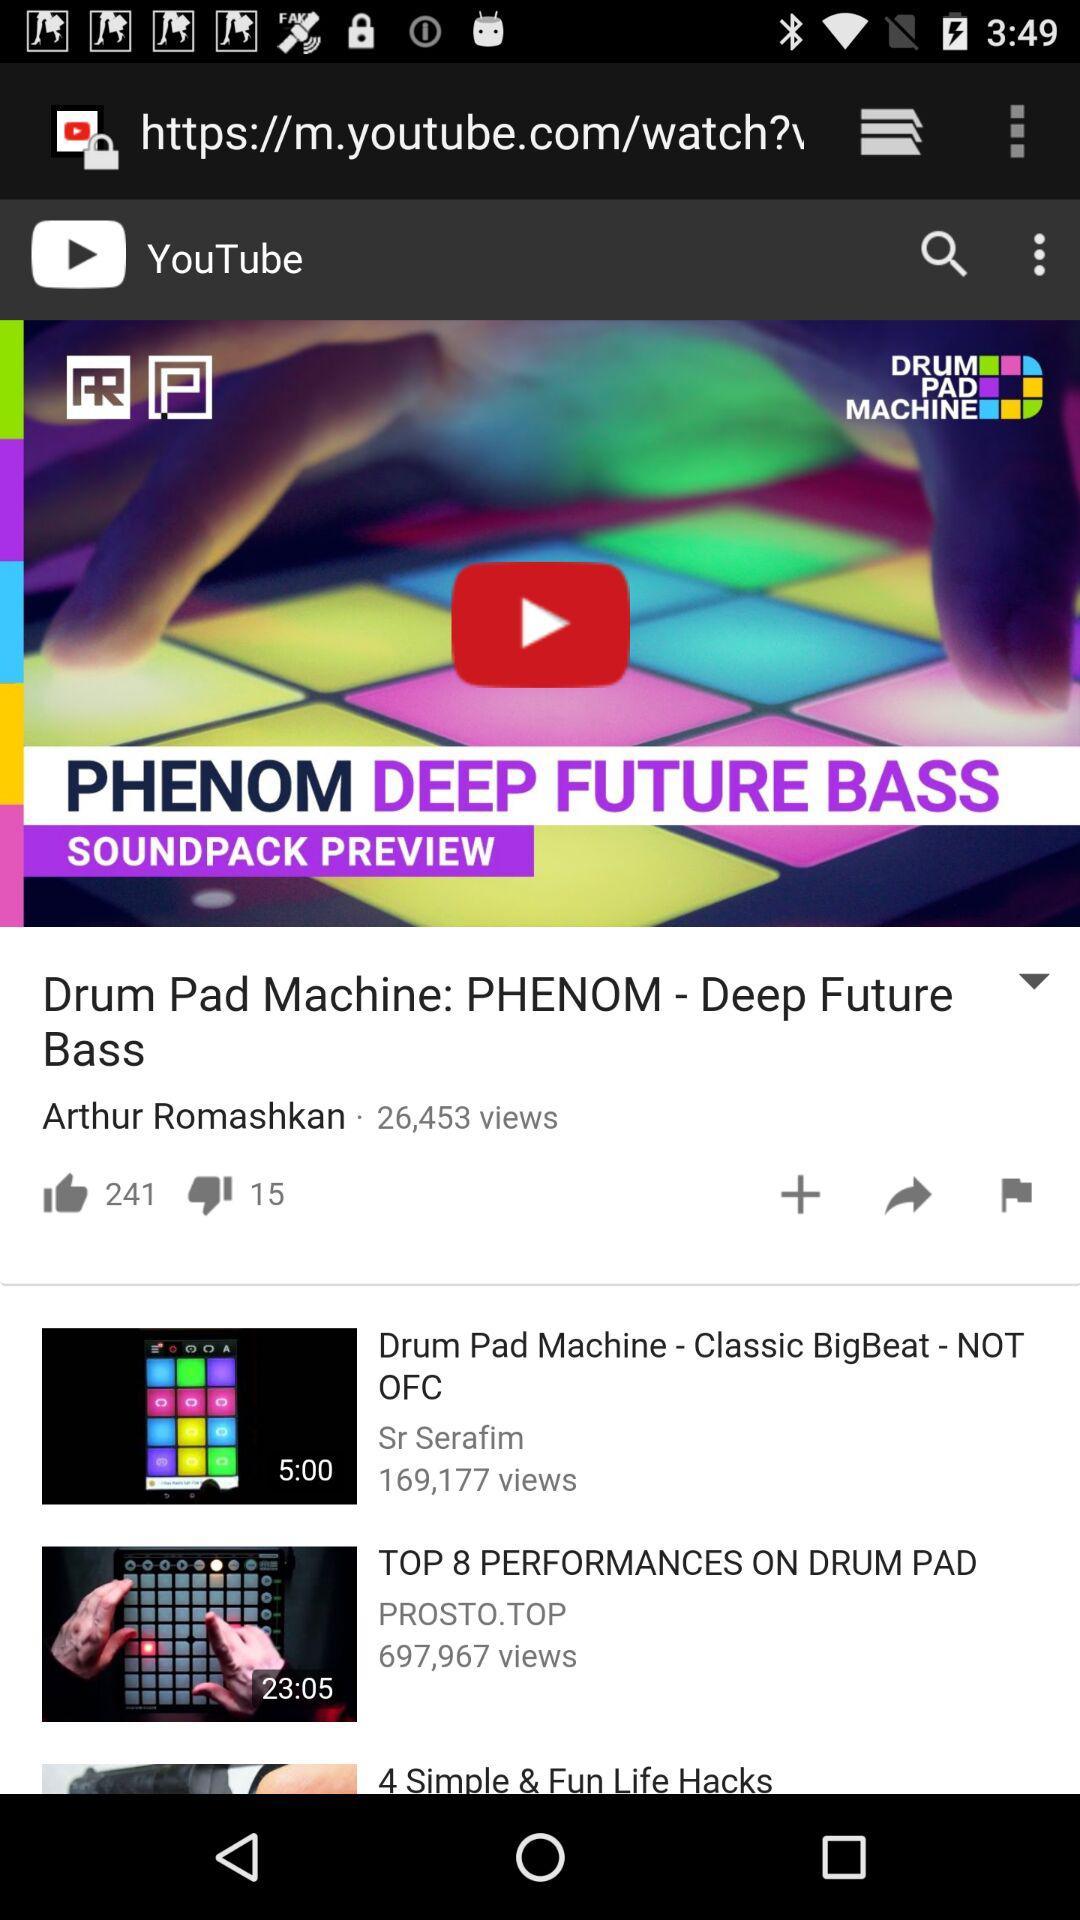What is the duration of "Drum Pad Machine - Classic BigBeat - NOT OFC"? The duration is 5 minutes. 